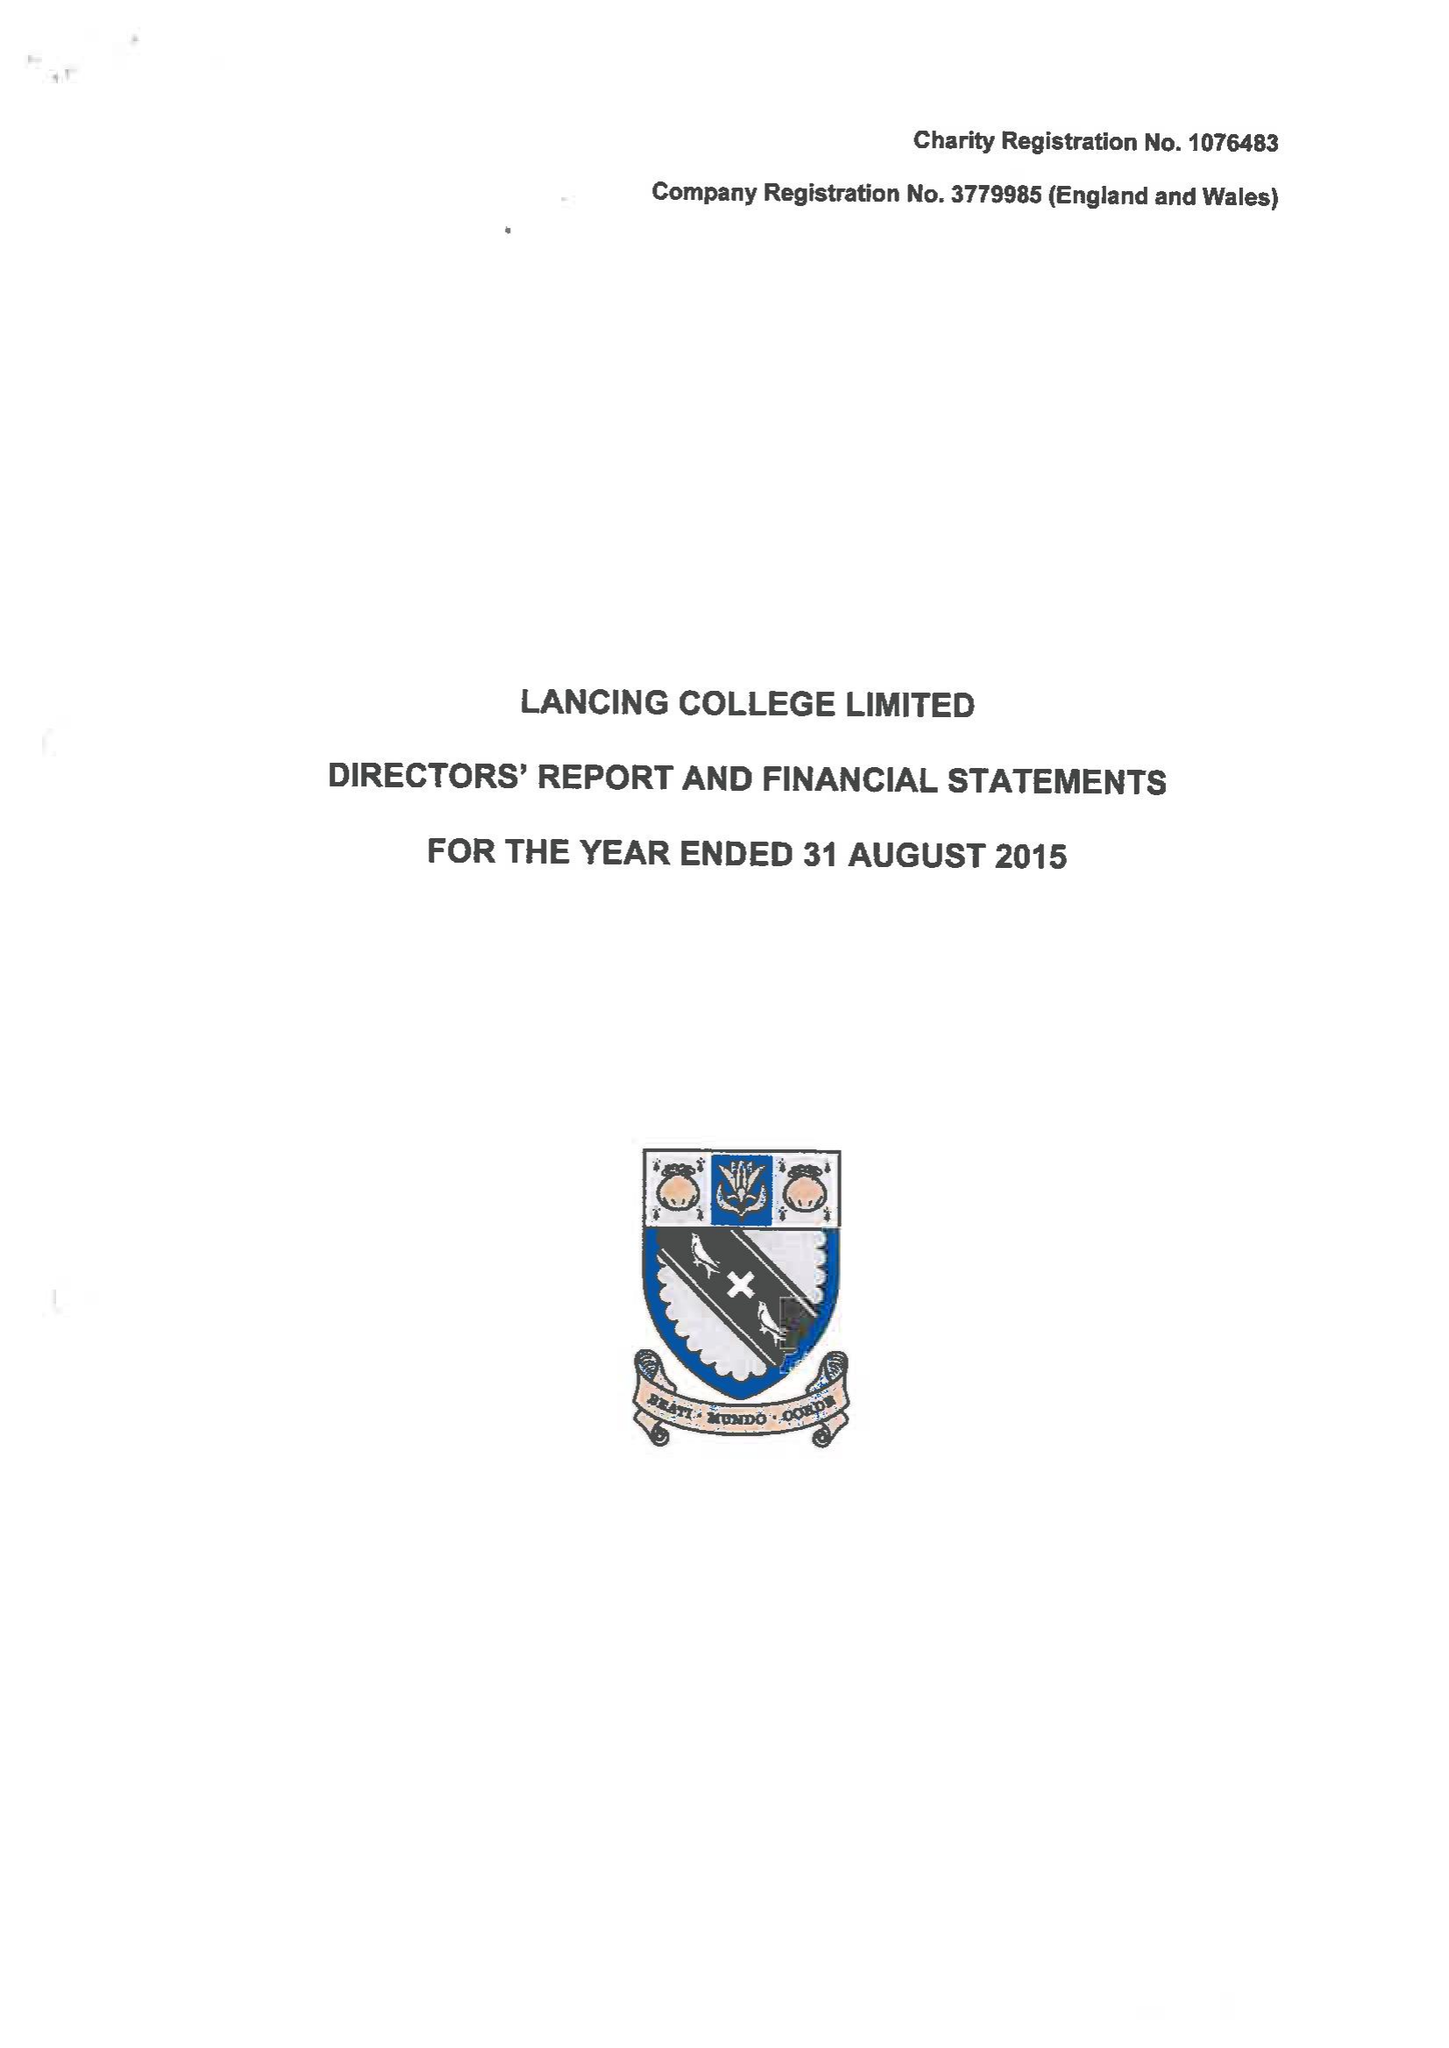What is the value for the address__postcode?
Answer the question using a single word or phrase. BN15 0RW 